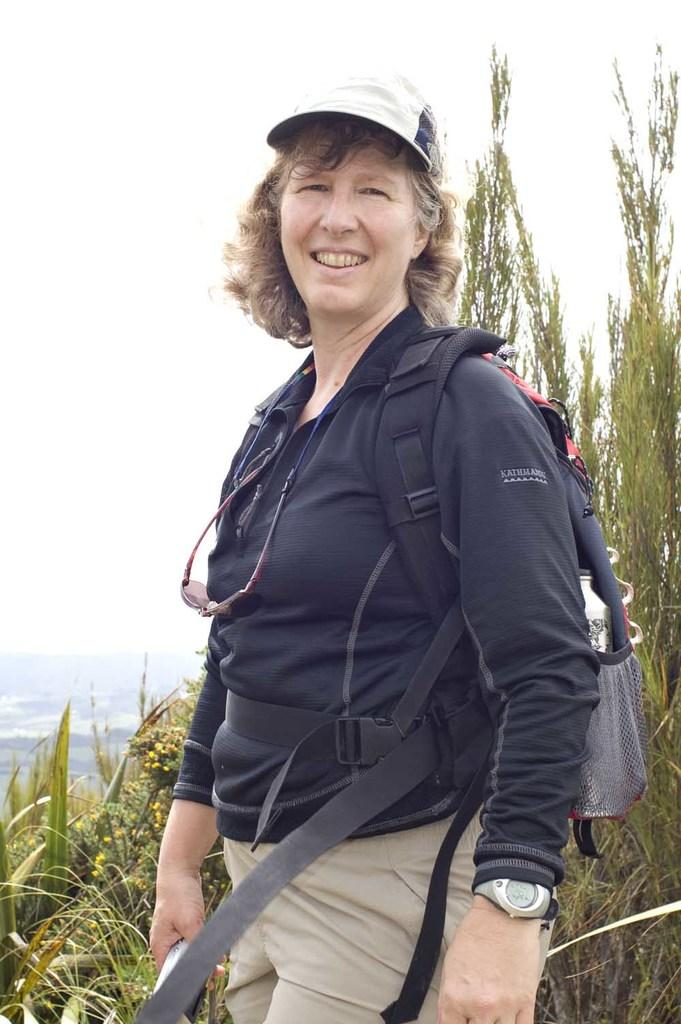Who is present in the image? There is a woman in the picture. What is the woman doing in the image? The woman is standing and smiling. What is the woman carrying in the image? The woman is carrying a backpack. What can be seen in the background of the picture? There are trees and the sky visible in the background of the picture. What type of kitten is playing chess with the woman in the image? There is no kitten or chess game present in the image. 